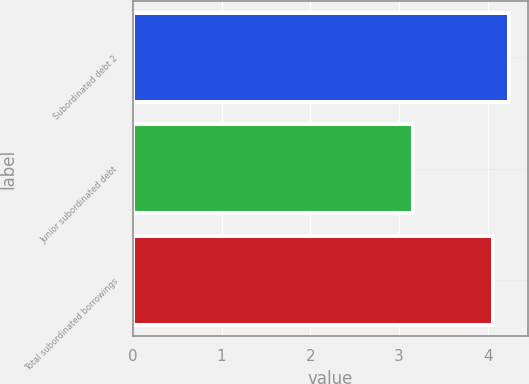Convert chart to OTSL. <chart><loc_0><loc_0><loc_500><loc_500><bar_chart><fcel>Subordinated debt 2<fcel>Junior subordinated debt<fcel>Total subordinated borrowings<nl><fcel>4.24<fcel>3.16<fcel>4.06<nl></chart> 